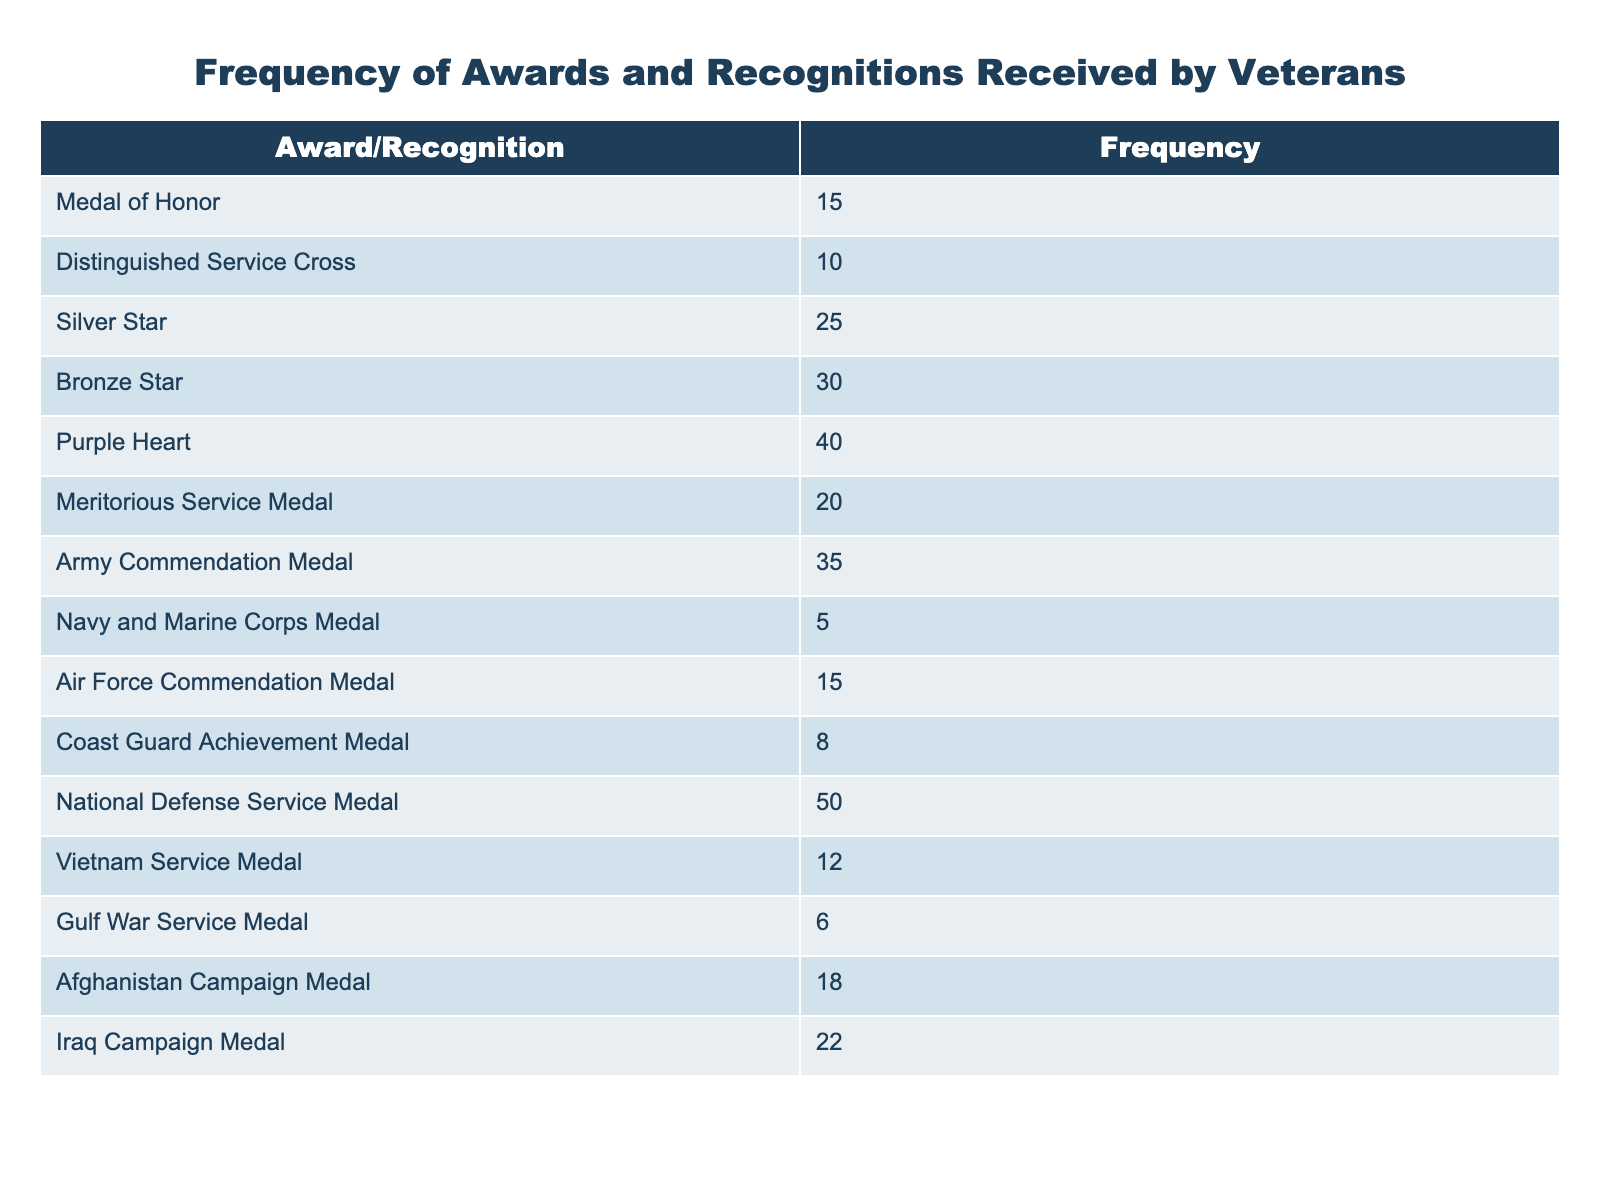What is the frequency of the Purple Heart award? The frequency of the Purple Heart award can be found by looking directly at the corresponding entry in the table. The table shows that the frequency is 40.
Answer: 40 Which award has the highest frequency? By scanning the table for the highest frequency value, it is clear that the National Defense Service Medal has the highest frequency, with a value of 50.
Answer: National Defense Service Medal How many awards have a frequency greater than 20? We need to count the awards listed in the table that have a frequency greater than 20. The awards with frequencies above 20 are Purple Heart (40), Bronze Star (30), Army Commendation Medal (35), and Silver Star (25). This gives us a total of 4 awards.
Answer: 4 What is the total frequency of the distinguished awards (Medal of Honor, Distinguished Service Cross, Silver Star, Bronze Star, and Purple Heart)? To find the total frequency of distinguished awards, we need to sum the frequencies of the awards listed: 15 (Medal of Honor) + 10 (Distinguished Service Cross) + 25 (Silver Star) + 30 (Bronze Star) + 40 (Purple Heart) = 120.
Answer: 120 Is the frequency of the Army Commendation Medal equal to the frequency of the Navy and Marine Corps Medal? The frequency of the Army Commendation Medal is 35, and the frequency of the Navy and Marine Corps Medal is 5, which are not equal; hence the answer is false.
Answer: No What is the average frequency of the awards? To find the average frequency, we have to sum the frequencies of all the awards and divide by the number of awards. The total frequency is 40 + 30 + 25 + 15 + 10 + 20 + 35 + 5 + 15 + 8 + 50 + 12 + 6 + 18 + 22 =  322. There are 15 different awards. Thus, the average is 322/15 = 21.47.
Answer: 21.47 How many awards received a frequency of less than 10? We can find the awards that received a frequency of less than 10 by checking the table. The awards that meet this criterion are the Navy and Marine Corps Medal (5) and Gulf War Service Medal (6), giving a total of 2 awards.
Answer: 2 Is the Purple Heart the only award with a frequency greater than 30? To answer this, we look at the frequencies in the table. The Purple Heart is at 40, but others with frequencies greater than 30 include Bronze Star (30) and Army Commendation Medal (35). Therefore, the statement is false.
Answer: No 